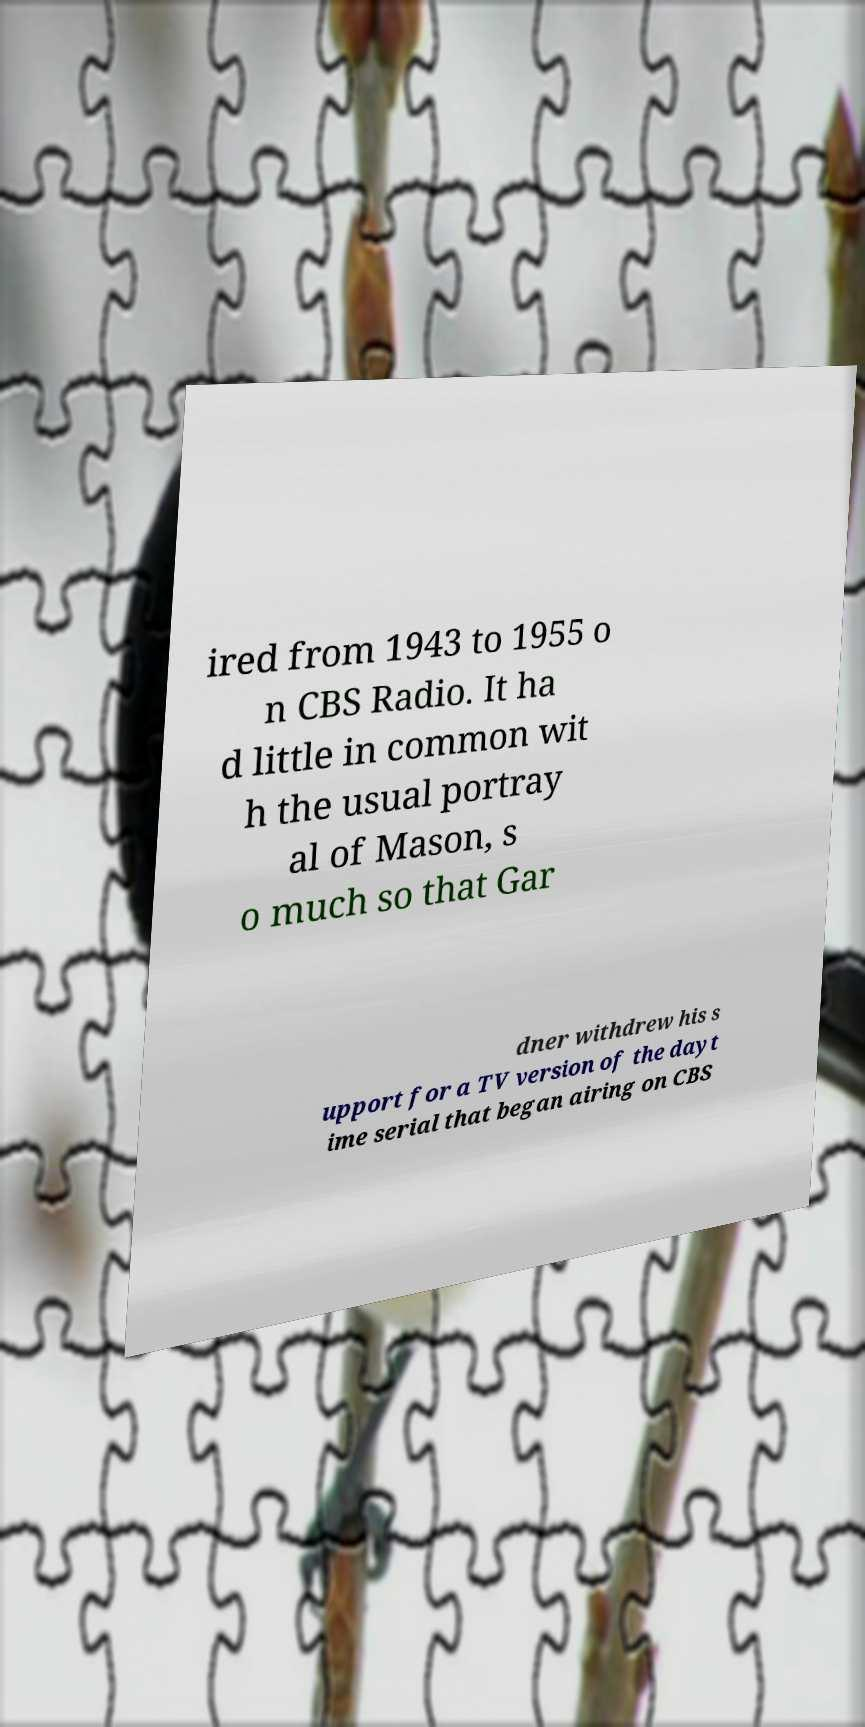Could you assist in decoding the text presented in this image and type it out clearly? ired from 1943 to 1955 o n CBS Radio. It ha d little in common wit h the usual portray al of Mason, s o much so that Gar dner withdrew his s upport for a TV version of the dayt ime serial that began airing on CBS 